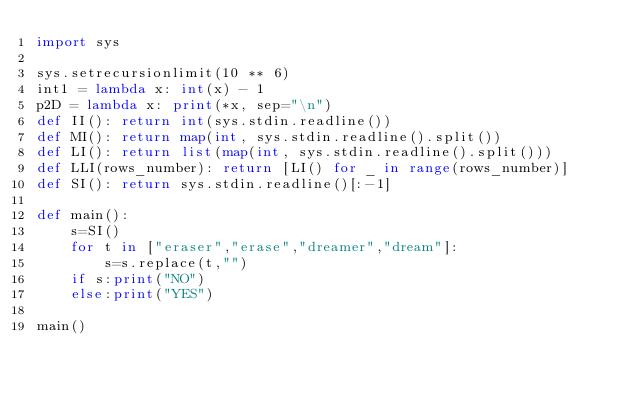Convert code to text. <code><loc_0><loc_0><loc_500><loc_500><_Python_>import sys

sys.setrecursionlimit(10 ** 6)
int1 = lambda x: int(x) - 1
p2D = lambda x: print(*x, sep="\n")
def II(): return int(sys.stdin.readline())
def MI(): return map(int, sys.stdin.readline().split())
def LI(): return list(map(int, sys.stdin.readline().split()))
def LLI(rows_number): return [LI() for _ in range(rows_number)]
def SI(): return sys.stdin.readline()[:-1]

def main():
    s=SI()
    for t in ["eraser","erase","dreamer","dream"]:
        s=s.replace(t,"")
    if s:print("NO")
    else:print("YES")

main()</code> 